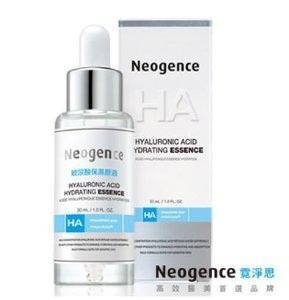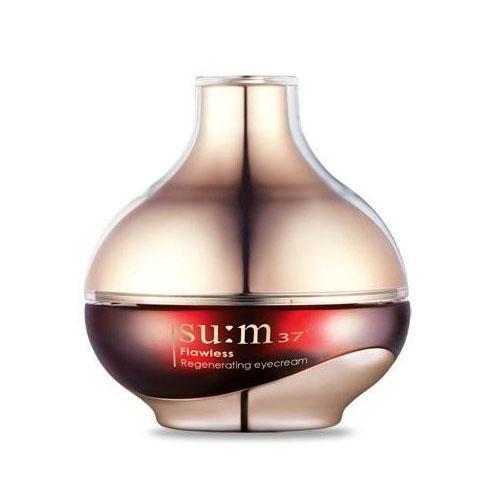The first image is the image on the left, the second image is the image on the right. Considering the images on both sides, is "A wide product box with pink writing are in both images." valid? Answer yes or no. No. The first image is the image on the left, the second image is the image on the right. Given the left and right images, does the statement "There is at least one bottle with no box or bag." hold true? Answer yes or no. Yes. 